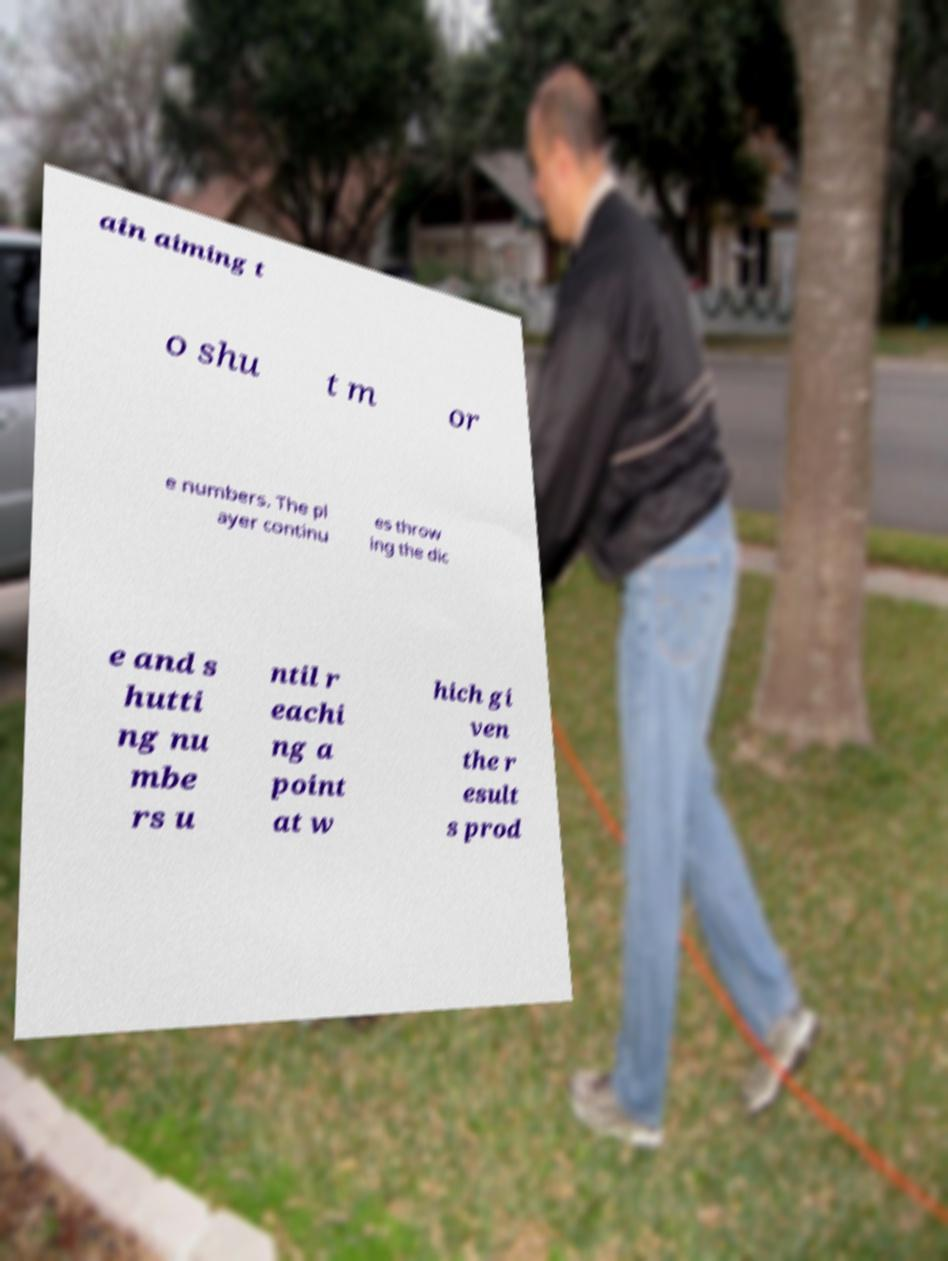Can you accurately transcribe the text from the provided image for me? ain aiming t o shu t m or e numbers. The pl ayer continu es throw ing the dic e and s hutti ng nu mbe rs u ntil r eachi ng a point at w hich gi ven the r esult s prod 